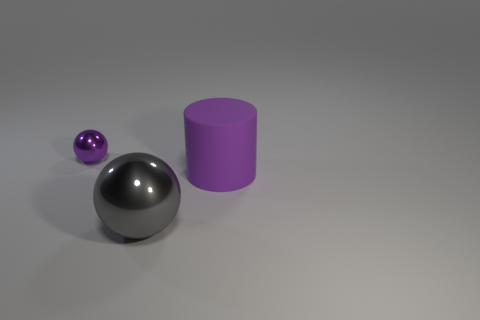Add 2 gray balls. How many objects exist? 5 Subtract all cylinders. How many objects are left? 2 Subtract all large gray balls. Subtract all tiny brown metallic blocks. How many objects are left? 2 Add 3 large metallic objects. How many large metallic objects are left? 4 Add 1 gray objects. How many gray objects exist? 2 Subtract 0 brown cylinders. How many objects are left? 3 Subtract all gray balls. Subtract all green cylinders. How many balls are left? 1 